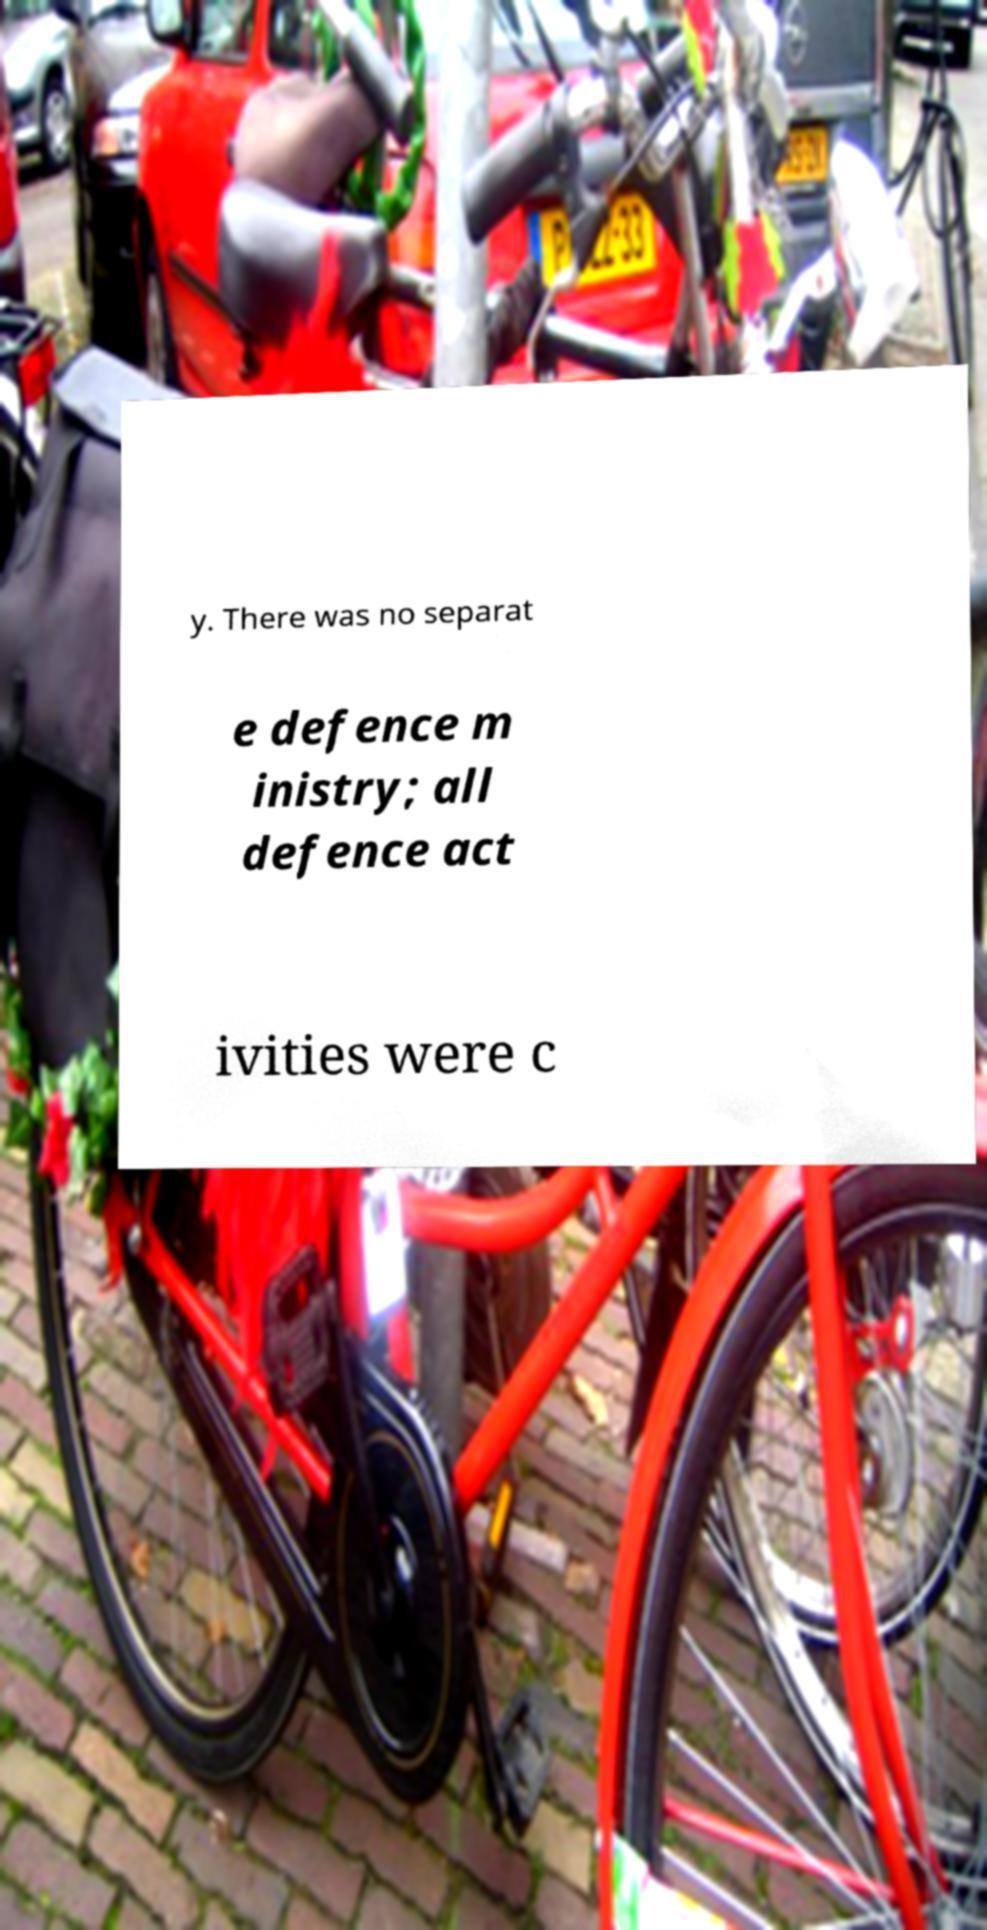For documentation purposes, I need the text within this image transcribed. Could you provide that? y. There was no separat e defence m inistry; all defence act ivities were c 